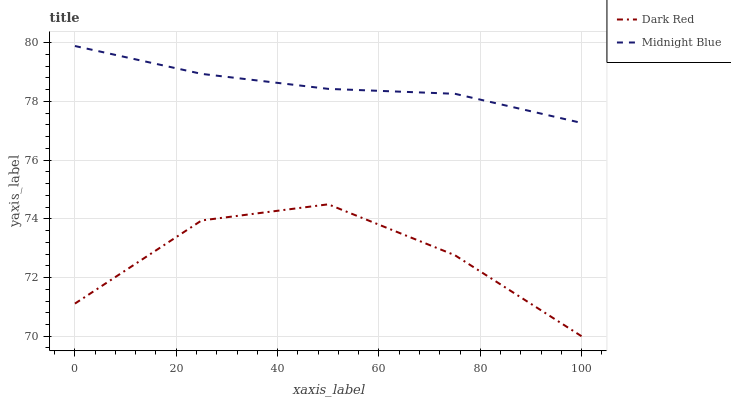Does Dark Red have the minimum area under the curve?
Answer yes or no. Yes. Does Midnight Blue have the maximum area under the curve?
Answer yes or no. Yes. Does Midnight Blue have the minimum area under the curve?
Answer yes or no. No. Is Midnight Blue the smoothest?
Answer yes or no. Yes. Is Dark Red the roughest?
Answer yes or no. Yes. Is Midnight Blue the roughest?
Answer yes or no. No. Does Dark Red have the lowest value?
Answer yes or no. Yes. Does Midnight Blue have the lowest value?
Answer yes or no. No. Does Midnight Blue have the highest value?
Answer yes or no. Yes. Is Dark Red less than Midnight Blue?
Answer yes or no. Yes. Is Midnight Blue greater than Dark Red?
Answer yes or no. Yes. Does Dark Red intersect Midnight Blue?
Answer yes or no. No. 